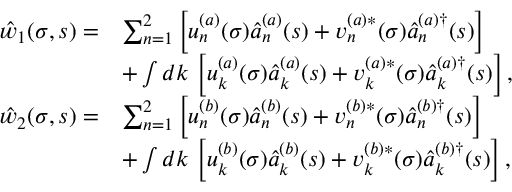Convert formula to latex. <formula><loc_0><loc_0><loc_500><loc_500>\begin{array} { r l } { { \hat { w } } _ { 1 } ( \sigma , s ) = } & { \sum _ { n = 1 } ^ { 2 } \left [ u _ { n } ^ { ( a ) } ( \sigma ) \hat { a } _ { n } ^ { ( a ) } ( s ) + v _ { n } ^ { ( a ) \ast } ( \sigma ) \hat { a } _ { n } ^ { ( a ) \dagger } ( s ) \right ] } \\ & { + \int d k \, \left [ u _ { k } ^ { ( a ) } ( \sigma ) \hat { a } _ { k } ^ { ( a ) } ( s ) + v _ { k } ^ { ( a ) \ast } ( \sigma ) \hat { a } _ { k } ^ { ( a ) \dagger } ( s ) \right ] , } \\ { { \hat { w } } _ { 2 } ( \sigma , s ) = } & { \sum _ { n = 1 } ^ { 2 } \left [ u _ { n } ^ { ( b ) } ( \sigma ) \hat { a } _ { n } ^ { ( b ) } ( s ) + v _ { n } ^ { ( b ) \ast } ( \sigma ) \hat { a } _ { n } ^ { ( b ) \dagger } ( s ) \right ] } \\ & { + \int d k \, \left [ u _ { k } ^ { ( b ) } ( \sigma ) \hat { a } _ { k } ^ { ( b ) } ( s ) + v _ { k } ^ { ( b ) \ast } ( \sigma ) \hat { a } _ { k } ^ { ( b ) \dagger } ( s ) \right ] , } \end{array}</formula> 